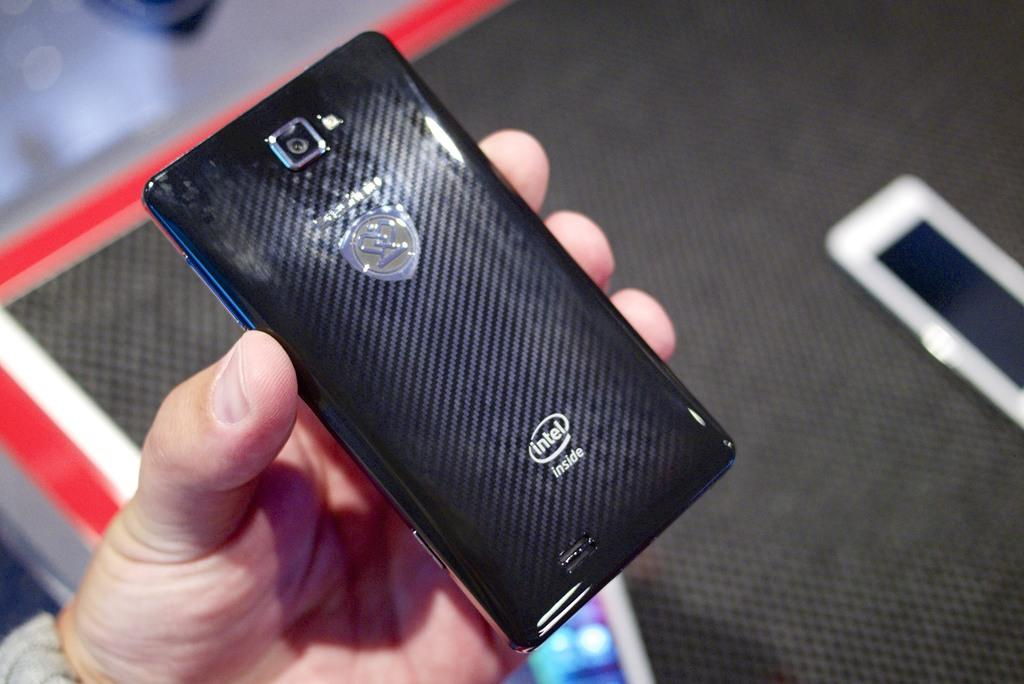<image>
Offer a succinct explanation of the picture presented. the back side of an Intel inside phone held in a hand 